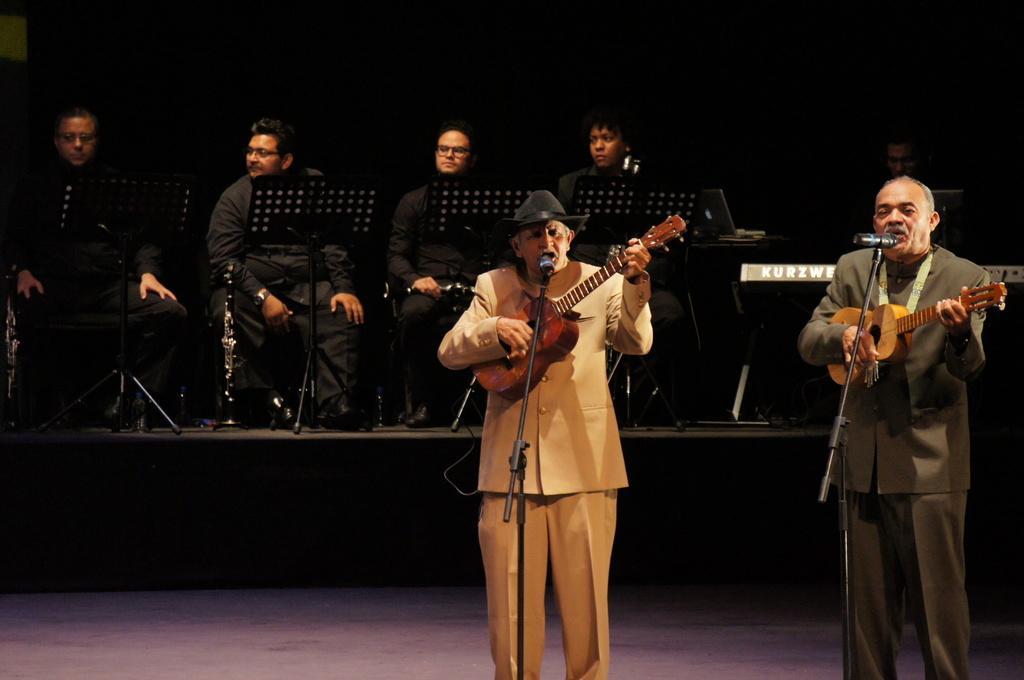In one or two sentences, can you explain what this image depicts? In this image I can see a person wearing cream colored dress and another person wearing grey colored dress are standing and holding musical instruments in their hands. I can see microphones in front of them. In the background I can see few other persons wearing black colored dresses are sitting and the dark background. 